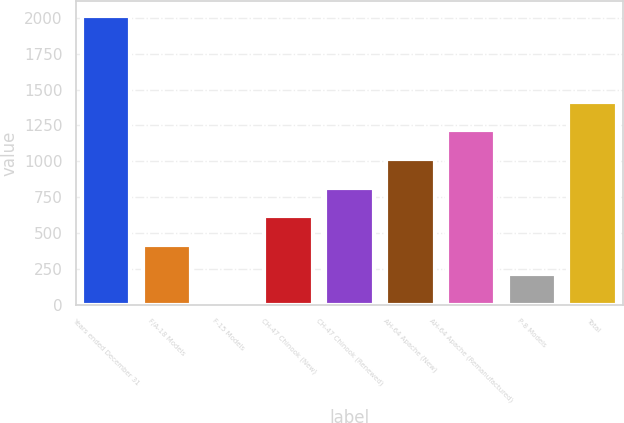Convert chart to OTSL. <chart><loc_0><loc_0><loc_500><loc_500><bar_chart><fcel>Years ended December 31<fcel>F/A-18 Models<fcel>F-15 Models<fcel>CH-47 Chinook (New)<fcel>CH-47 Chinook (Renewed)<fcel>AH-64 Apache (New)<fcel>AH-64 Apache (Remanufactured)<fcel>P-8 Models<fcel>Total<nl><fcel>2016<fcel>415.2<fcel>15<fcel>615.3<fcel>815.4<fcel>1015.5<fcel>1215.6<fcel>215.1<fcel>1415.7<nl></chart> 